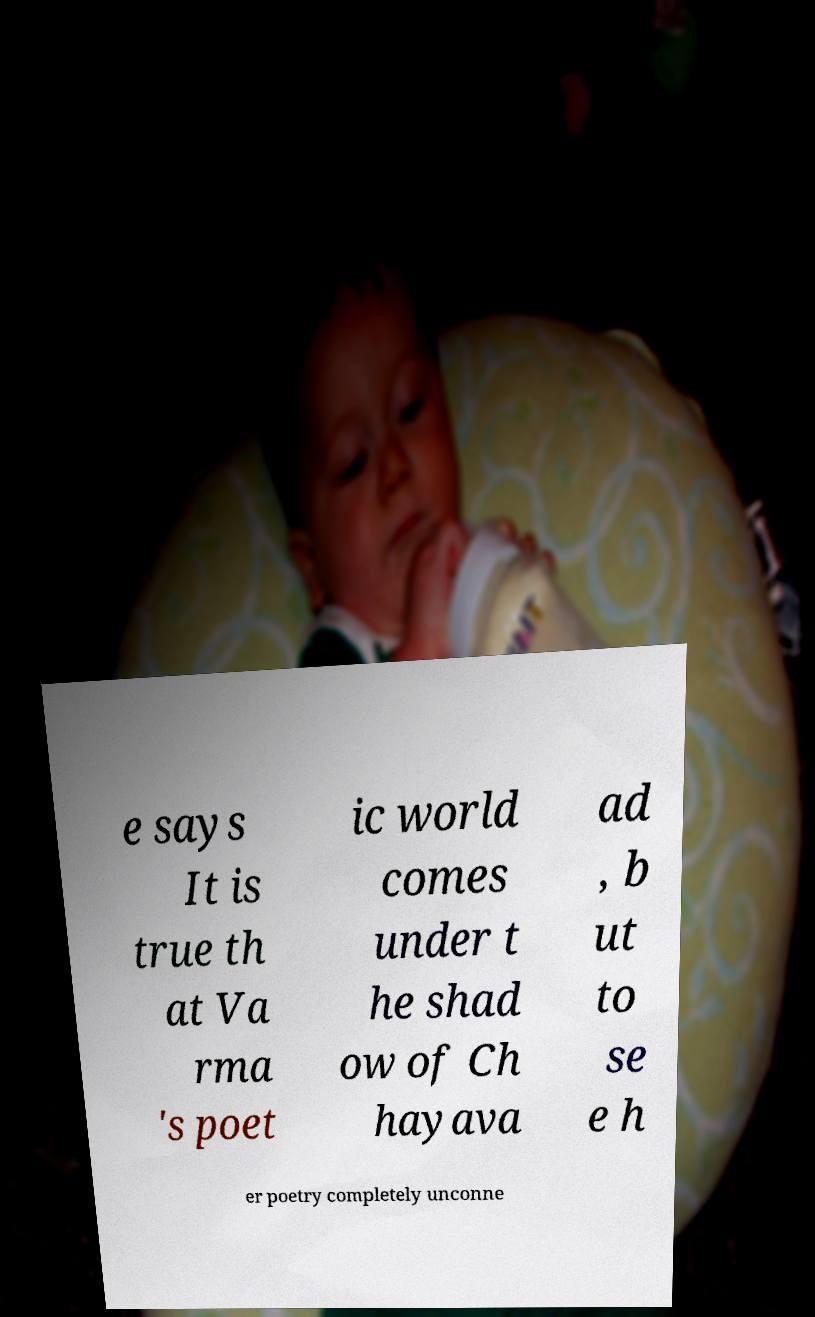For documentation purposes, I need the text within this image transcribed. Could you provide that? e says It is true th at Va rma 's poet ic world comes under t he shad ow of Ch hayava ad , b ut to se e h er poetry completely unconne 